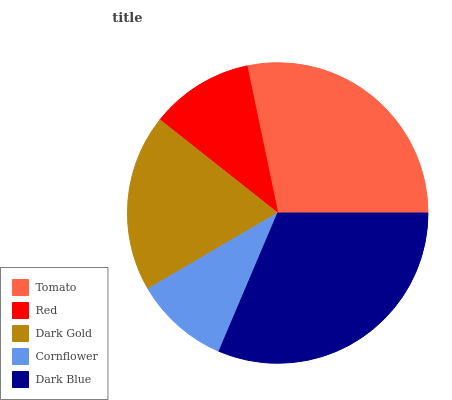Is Cornflower the minimum?
Answer yes or no. Yes. Is Dark Blue the maximum?
Answer yes or no. Yes. Is Red the minimum?
Answer yes or no. No. Is Red the maximum?
Answer yes or no. No. Is Tomato greater than Red?
Answer yes or no. Yes. Is Red less than Tomato?
Answer yes or no. Yes. Is Red greater than Tomato?
Answer yes or no. No. Is Tomato less than Red?
Answer yes or no. No. Is Dark Gold the high median?
Answer yes or no. Yes. Is Dark Gold the low median?
Answer yes or no. Yes. Is Tomato the high median?
Answer yes or no. No. Is Cornflower the low median?
Answer yes or no. No. 